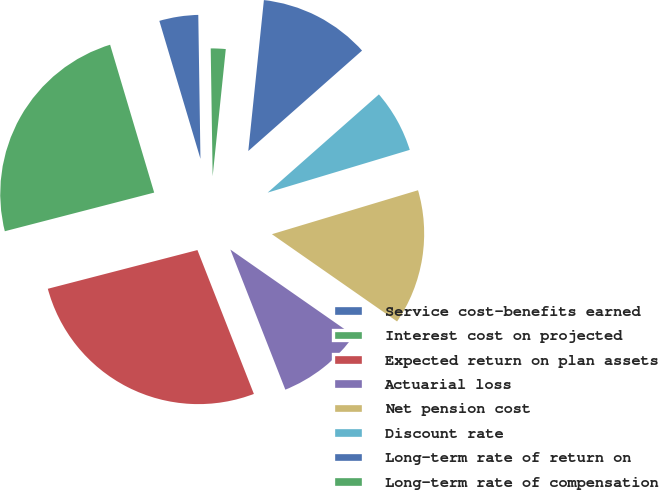Convert chart to OTSL. <chart><loc_0><loc_0><loc_500><loc_500><pie_chart><fcel>Service cost-benefits earned<fcel>Interest cost on projected<fcel>Expected return on plan assets<fcel>Actuarial loss<fcel>Net pension cost<fcel>Discount rate<fcel>Long-term rate of return on<fcel>Long-term rate of compensation<nl><fcel>4.37%<fcel>24.42%<fcel>26.92%<fcel>9.36%<fcel>14.34%<fcel>6.86%<fcel>11.85%<fcel>1.88%<nl></chart> 